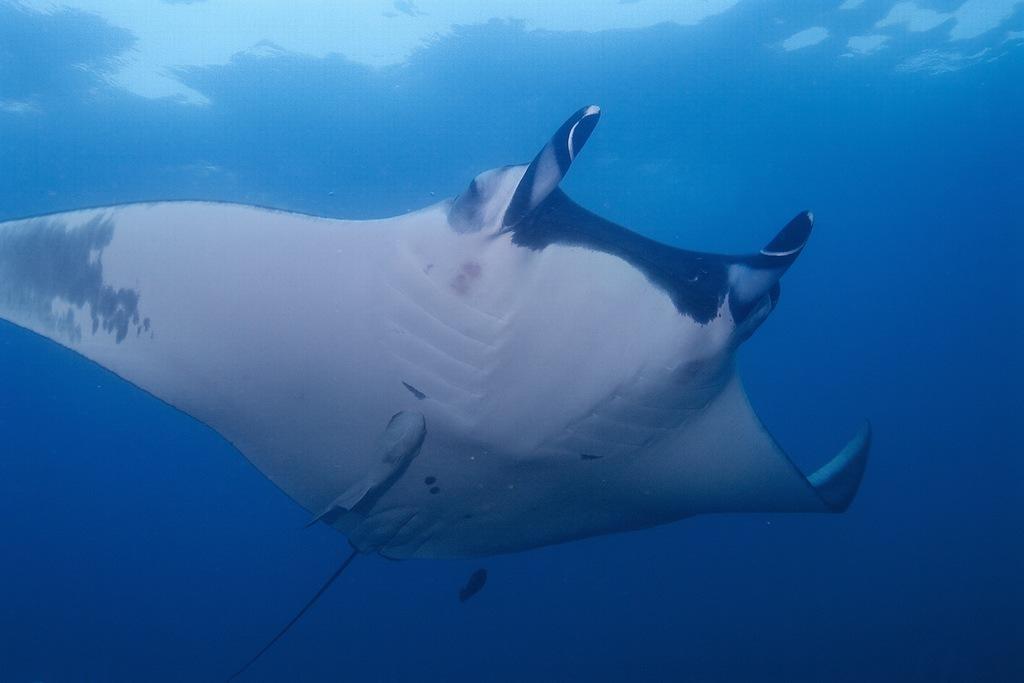In one or two sentences, can you explain what this image depicts? In the image there is a fish swimming under the water. 